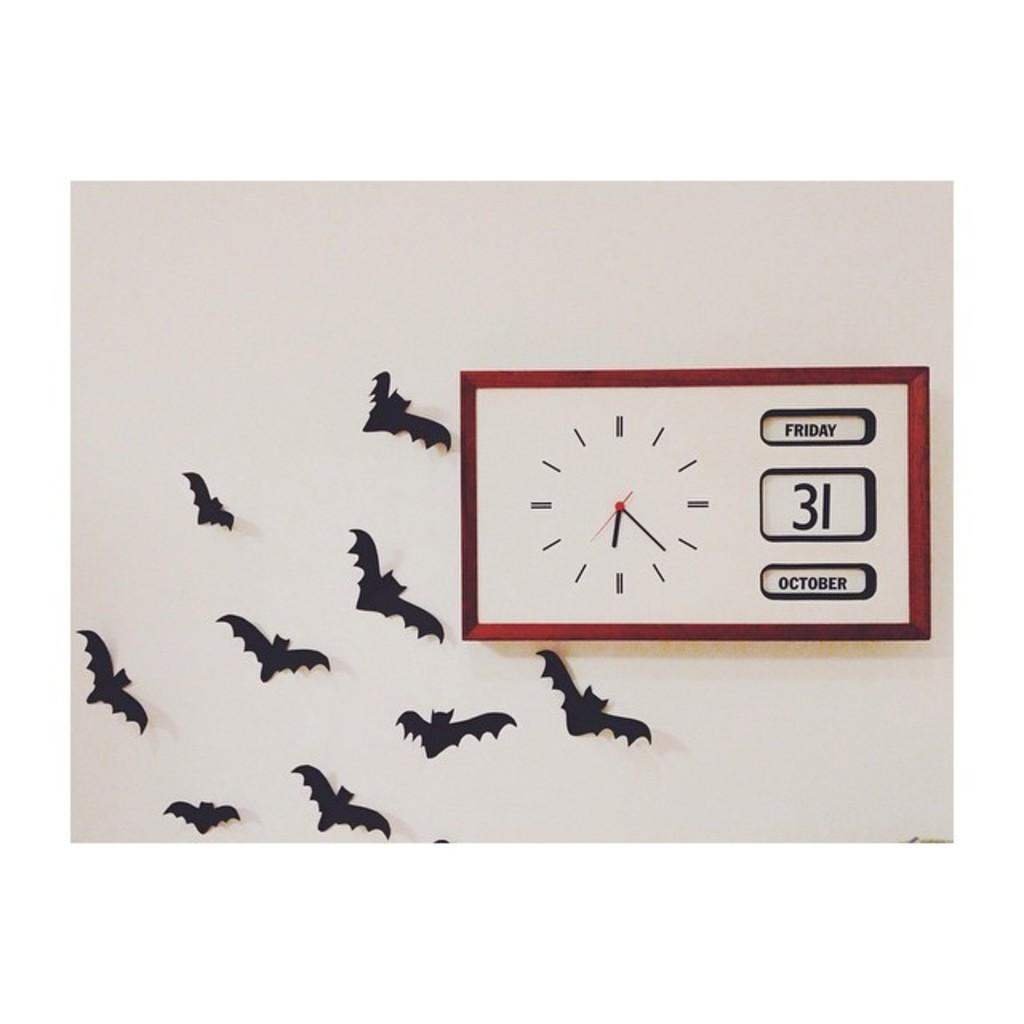<image>
Relay a brief, clear account of the picture shown. Some bats next to a clock which says Friday on it. 